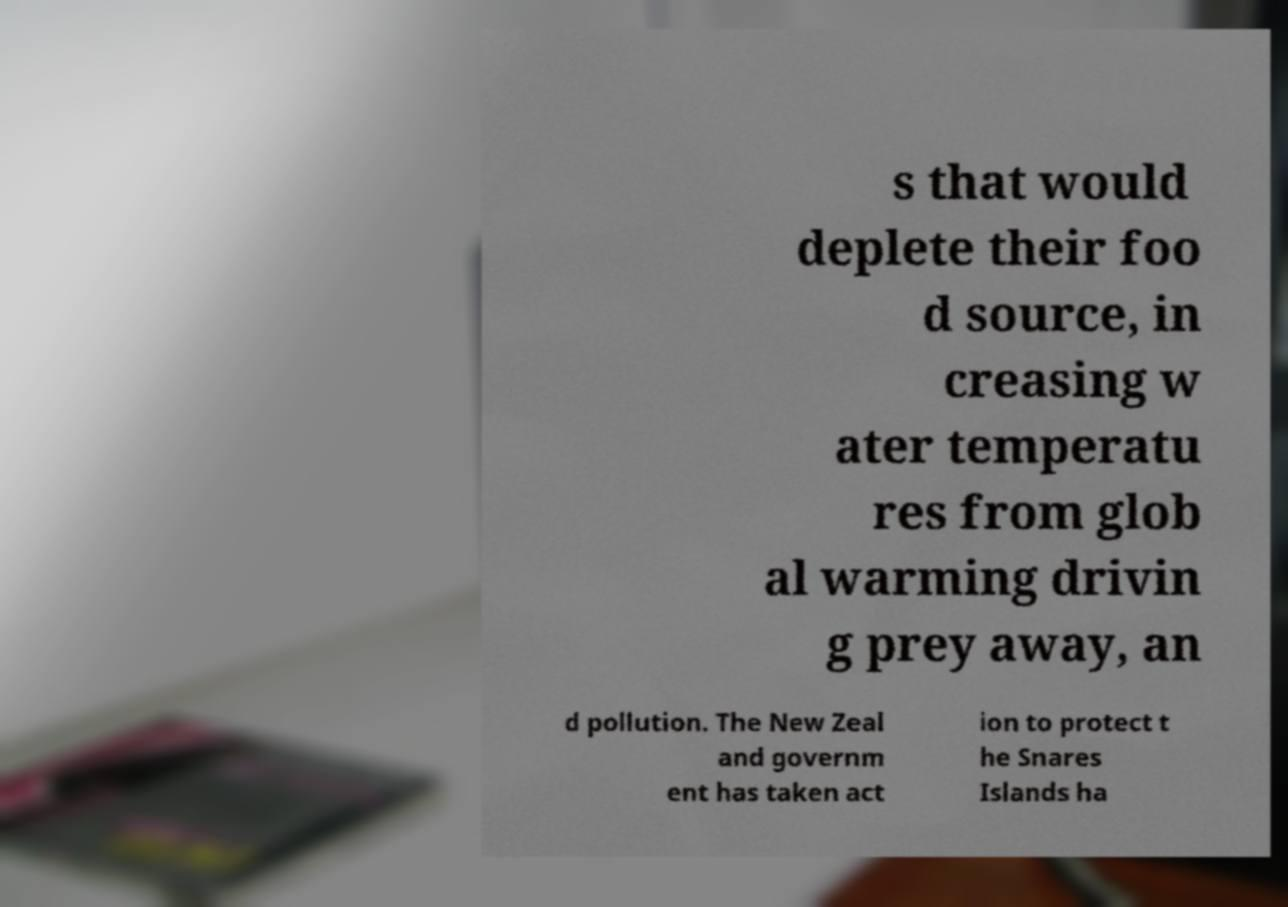Could you assist in decoding the text presented in this image and type it out clearly? s that would deplete their foo d source, in creasing w ater temperatu res from glob al warming drivin g prey away, an d pollution. The New Zeal and governm ent has taken act ion to protect t he Snares Islands ha 